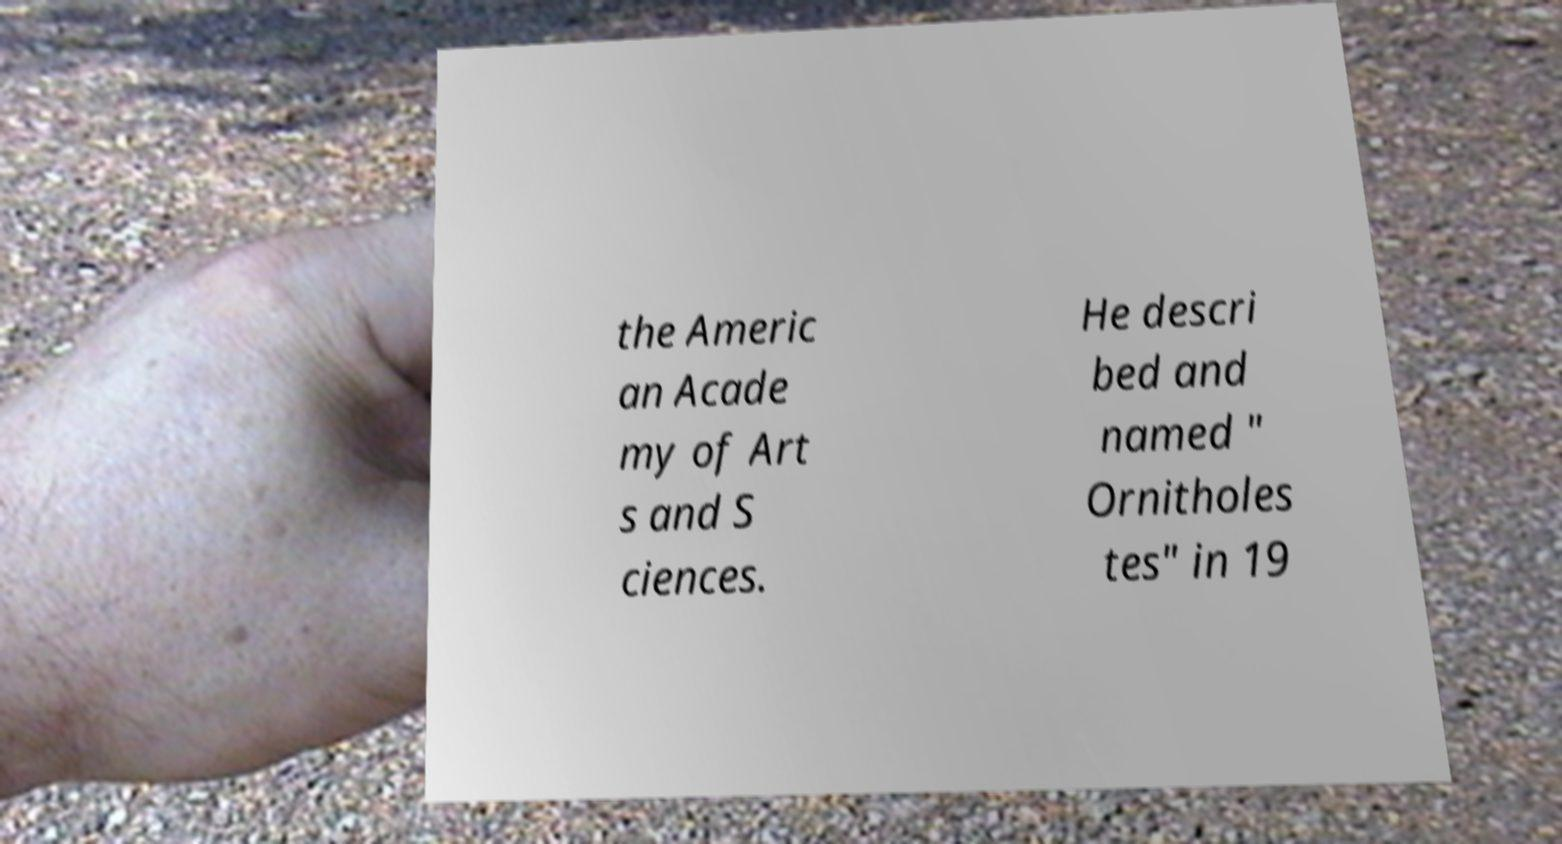Please read and relay the text visible in this image. What does it say? the Americ an Acade my of Art s and S ciences. He descri bed and named " Ornitholes tes" in 19 